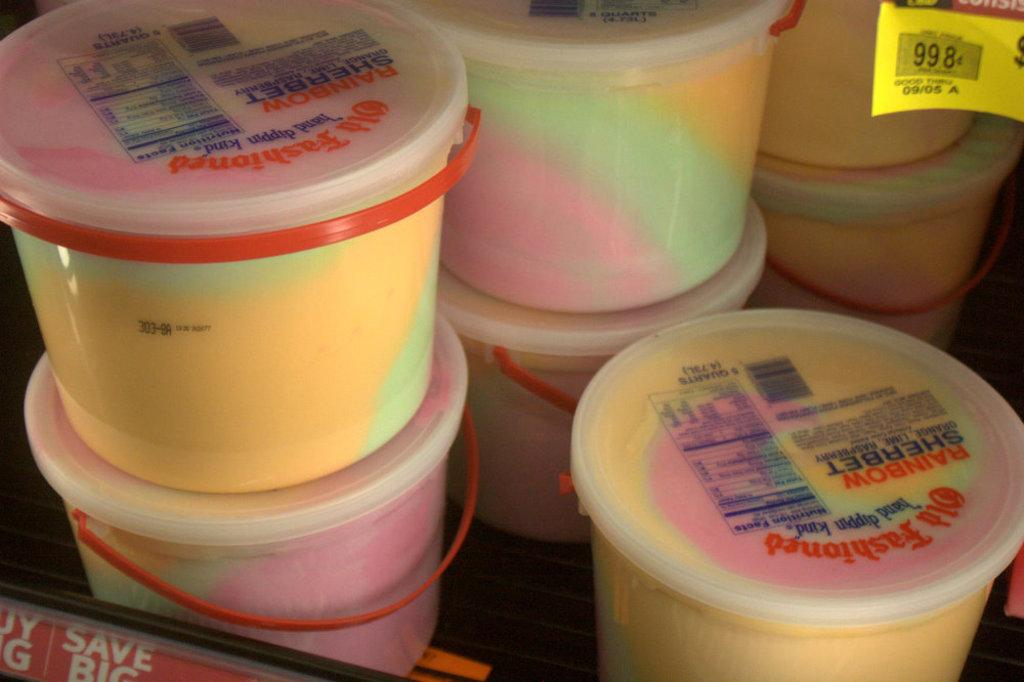Provide a one-sentence caption for the provided image. A stack of containers of Old Fashioned rainbow sherbet. 